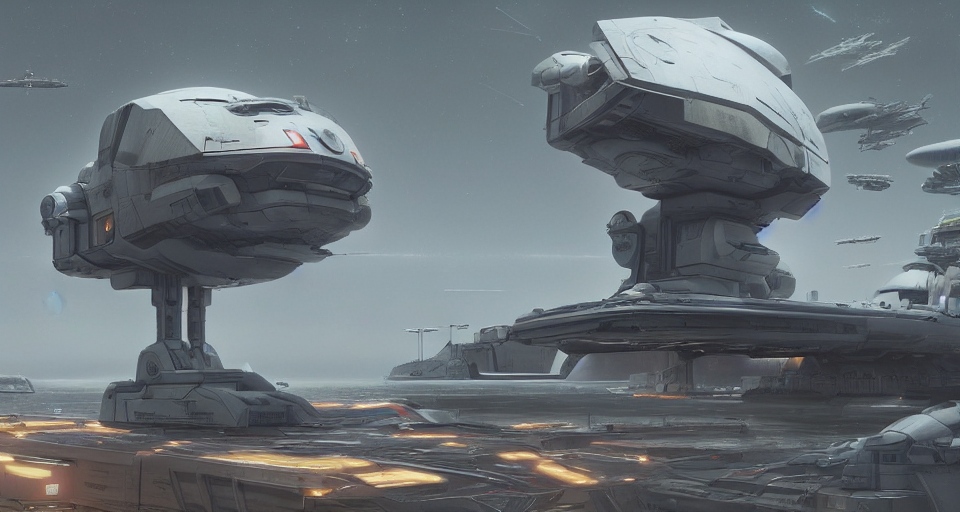Can you describe the vehicles shown in the image? Certainly, the image showcases a variety of impressive spacecraft. There are large carriers with robust hulls, possibly for transporting goods or troops. Smaller, sleeker ships that resemble fighters due to their aerodynamic builds can also be seen, suggesting a blend of military and commercial activities in this facility. 